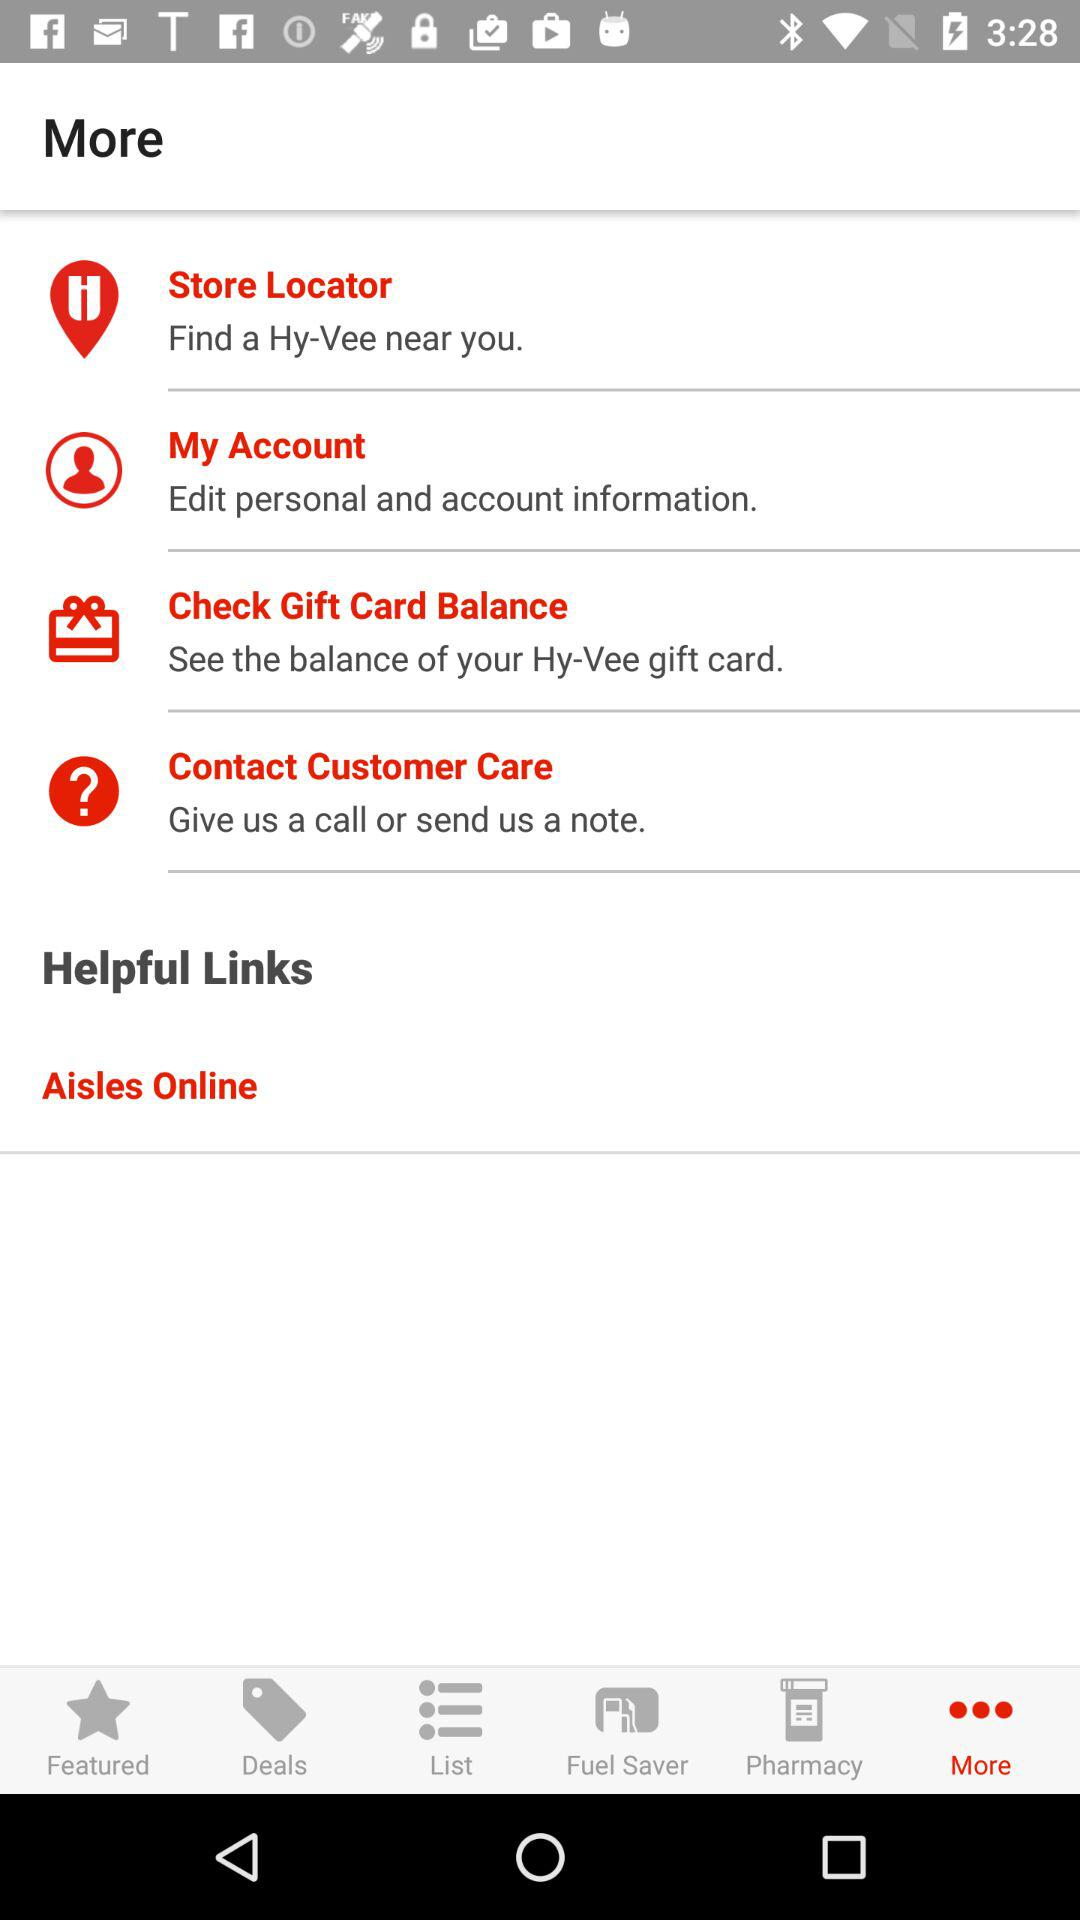Which tab is selected? The selected tab is "More". 